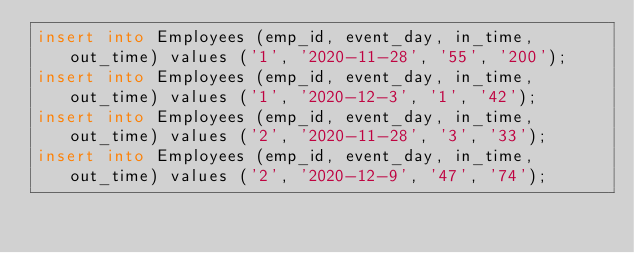Convert code to text. <code><loc_0><loc_0><loc_500><loc_500><_SQL_>insert into Employees (emp_id, event_day, in_time, out_time) values ('1', '2020-11-28', '55', '200');
insert into Employees (emp_id, event_day, in_time, out_time) values ('1', '2020-12-3', '1', '42');
insert into Employees (emp_id, event_day, in_time, out_time) values ('2', '2020-11-28', '3', '33');
insert into Employees (emp_id, event_day, in_time, out_time) values ('2', '2020-12-9', '47', '74');
</code> 